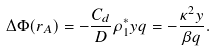Convert formula to latex. <formula><loc_0><loc_0><loc_500><loc_500>\Delta \Phi ( r _ { A } ) = - \frac { C _ { d } } { D } \rho ^ { * } _ { 1 } y q = - \frac { \kappa ^ { 2 } y } { \beta q } .</formula> 